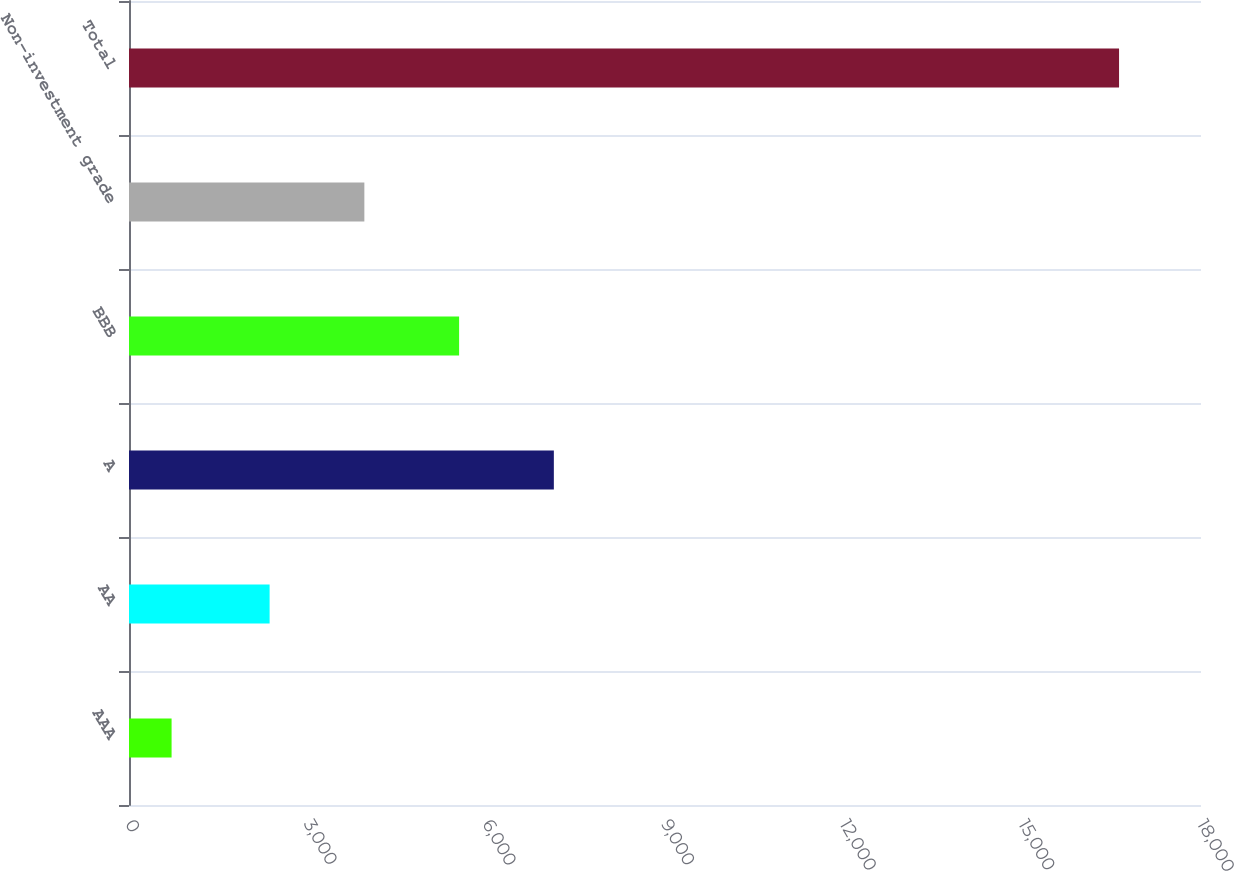<chart> <loc_0><loc_0><loc_500><loc_500><bar_chart><fcel>AAA<fcel>AA<fcel>A<fcel>BBB<fcel>Non-investment grade<fcel>Total<nl><fcel>715<fcel>2361<fcel>7133.7<fcel>5542.8<fcel>3951.9<fcel>16624<nl></chart> 